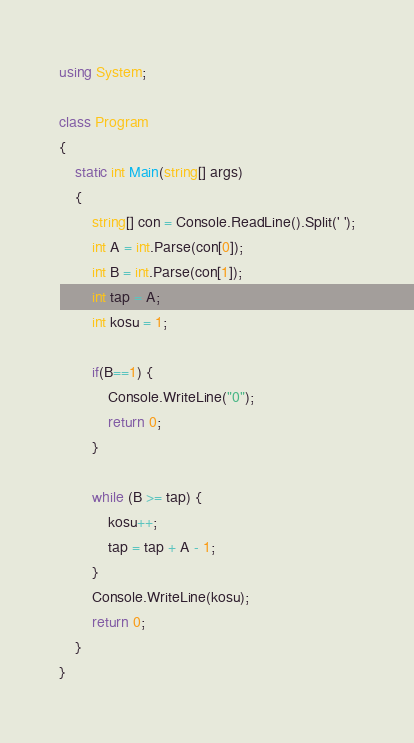<code> <loc_0><loc_0><loc_500><loc_500><_C#_>using System;

class Program
{
	static int Main(string[] args)
	{
		string[] con = Console.ReadLine().Split(' ');
		int A = int.Parse(con[0]);
		int B = int.Parse(con[1]);
		int tap = A;
		int kosu = 1;
		
		if(B==1) {
			Console.WriteLine("0");
			return 0;
		}
		
		while (B >= tap) {
			kosu++;
			tap = tap + A - 1;
		}
		Console.WriteLine(kosu);
		return 0;
	}
}</code> 